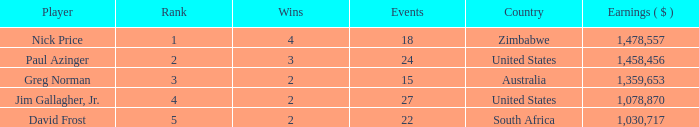How many events are in South Africa? 22.0. 